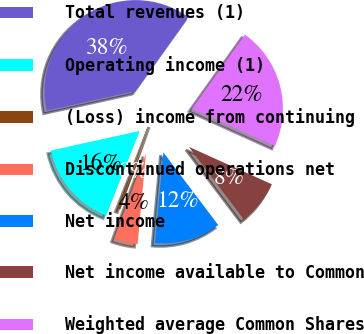<chart> <loc_0><loc_0><loc_500><loc_500><pie_chart><fcel>Total revenues (1)<fcel>Operating income (1)<fcel>(Loss) income from continuing<fcel>Discontinued operations net<fcel>Net income<fcel>Net income available to Common<fcel>Weighted average Common Shares<nl><fcel>38.33%<fcel>15.55%<fcel>0.37%<fcel>4.16%<fcel>11.76%<fcel>7.96%<fcel>21.87%<nl></chart> 